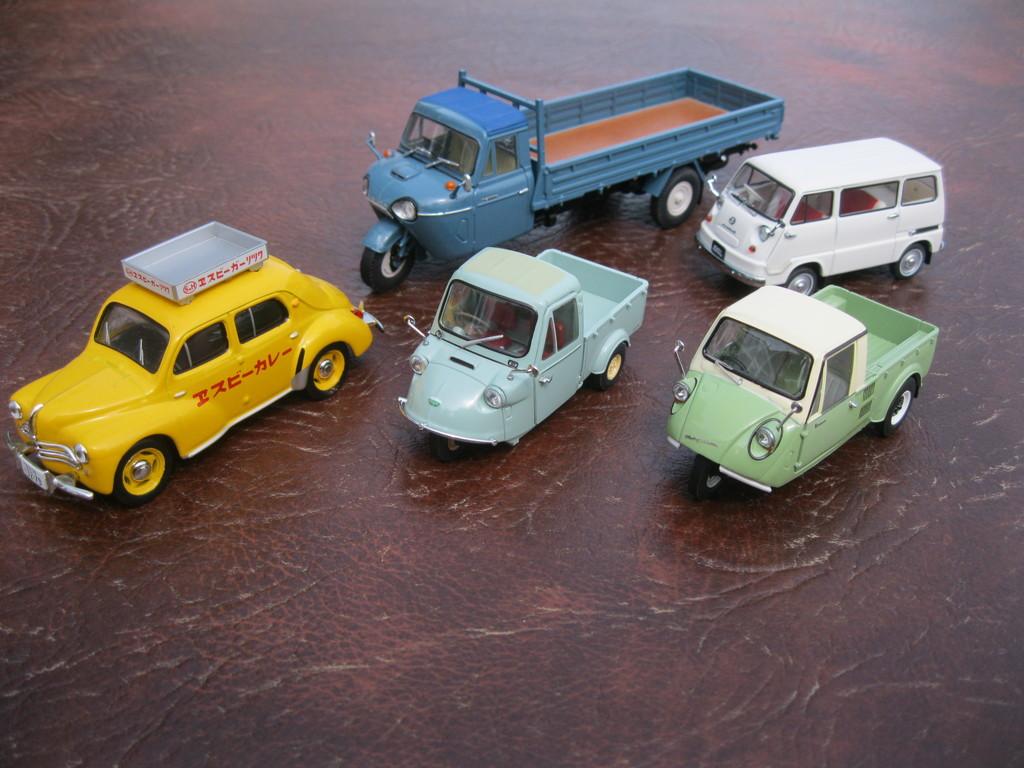What color is the car with the text?
Offer a very short reply. Yellow. 